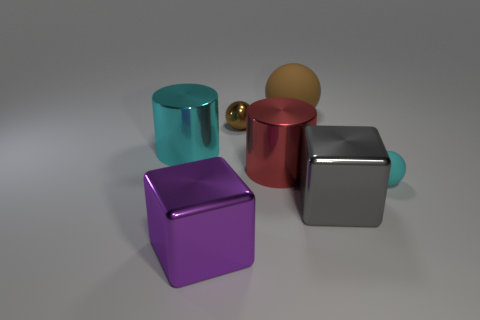What number of matte things are either big brown objects or green spheres?
Keep it short and to the point. 1. What shape is the brown object that is the same size as the purple cube?
Your answer should be very brief. Sphere. What number of things are metal cylinders that are on the left side of the big purple object or metallic objects left of the gray shiny cube?
Ensure brevity in your answer.  4. There is another object that is the same size as the brown metal object; what material is it?
Provide a short and direct response. Rubber. What number of other things are there of the same material as the big purple thing
Provide a short and direct response. 4. Are there an equal number of brown metal objects that are in front of the large purple block and cubes that are left of the tiny shiny object?
Give a very brief answer. No. What number of yellow objects are either cubes or big matte balls?
Your response must be concise. 0. Does the large ball have the same color as the large metal thing that is in front of the gray block?
Your answer should be compact. No. How many other things are the same color as the tiny rubber sphere?
Offer a very short reply. 1. Are there fewer cyan objects than blue rubber objects?
Your response must be concise. No. 